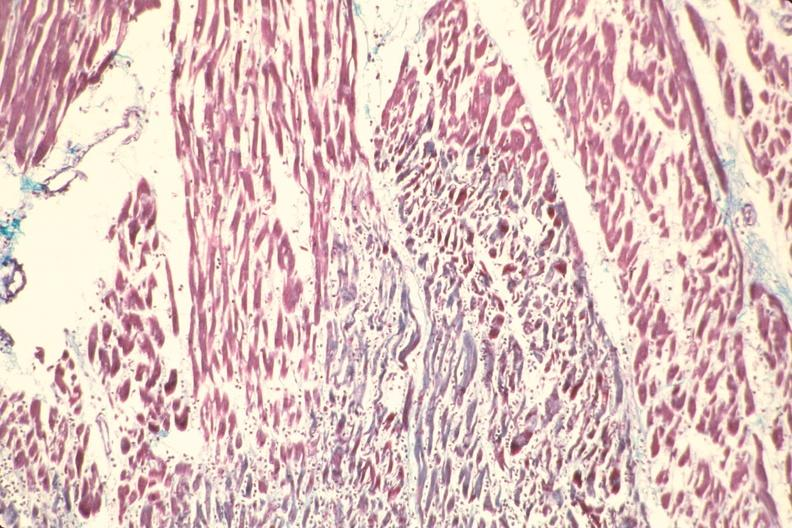does this image show heart, acute myocardial infarction?
Answer the question using a single word or phrase. Yes 